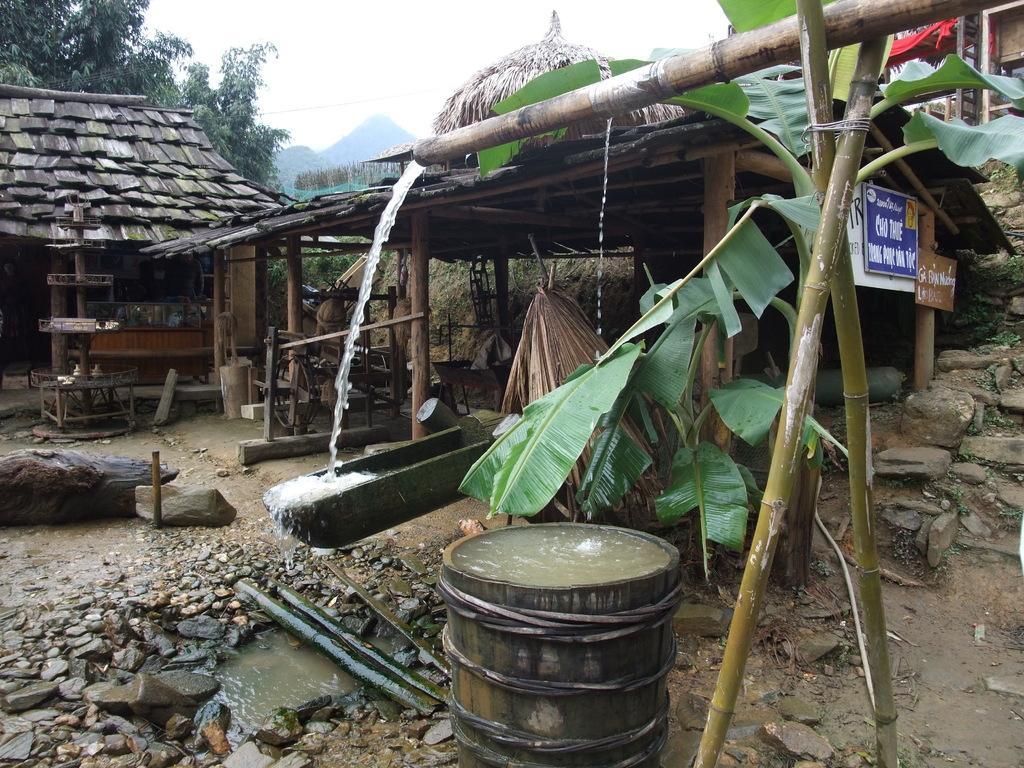In one or two sentences, can you explain what this image depicts? In this image there is a drum filled with water which is at the bottom of the image. Beside the drum there are two bamboo sticks tied with a rope. On it there is a pipe there is a pipe from which water is flowing out into a tub which is on the land having few rocks on it. Background there are few hits. Right side there is a tree. Few boards are attached to the hut. Few trees are at the left side of the image. Behind there are few hills. Top of the image there is sky. 